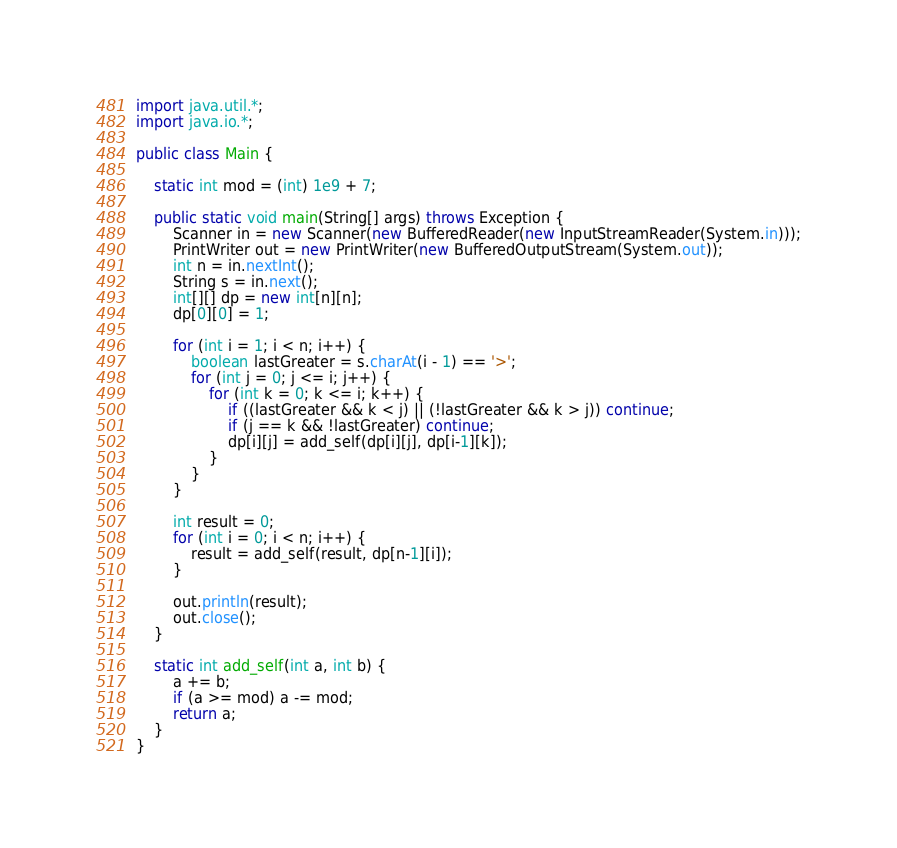<code> <loc_0><loc_0><loc_500><loc_500><_Java_>import java.util.*;
import java.io.*;

public class Main {

    static int mod = (int) 1e9 + 7;

    public static void main(String[] args) throws Exception {
        Scanner in = new Scanner(new BufferedReader(new InputStreamReader(System.in)));
        PrintWriter out = new PrintWriter(new BufferedOutputStream(System.out));
        int n = in.nextInt();
        String s = in.next();
        int[][] dp = new int[n][n];
        dp[0][0] = 1;

        for (int i = 1; i < n; i++) {
            boolean lastGreater = s.charAt(i - 1) == '>';
            for (int j = 0; j <= i; j++) {
                for (int k = 0; k <= i; k++) {
                    if ((lastGreater && k < j) || (!lastGreater && k > j)) continue;
                    if (j == k && !lastGreater) continue;
                    dp[i][j] = add_self(dp[i][j], dp[i-1][k]);
                }
            }
        }

        int result = 0;
        for (int i = 0; i < n; i++) {
            result = add_self(result, dp[n-1][i]);
        }

        out.println(result);
        out.close();
    }

    static int add_self(int a, int b) {
        a += b;
        if (a >= mod) a -= mod;
        return a;
    }
}</code> 